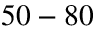<formula> <loc_0><loc_0><loc_500><loc_500>5 0 - 8 0</formula> 